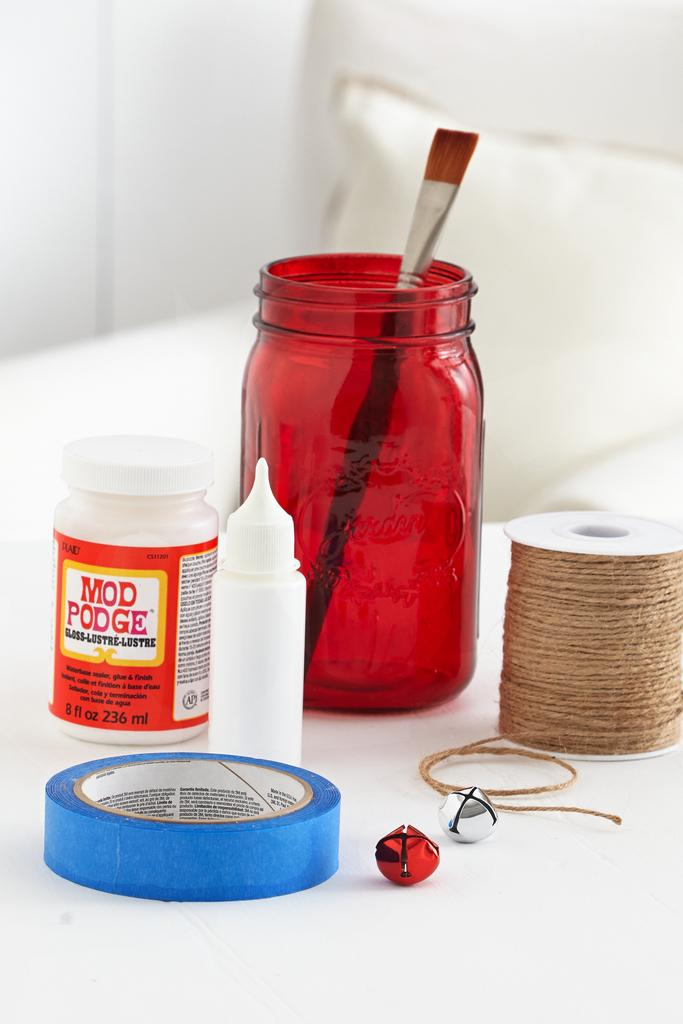Provide a one-sentence caption for the provided image. Crafting supplies, including Mod Podge, are arranged on a white table. 